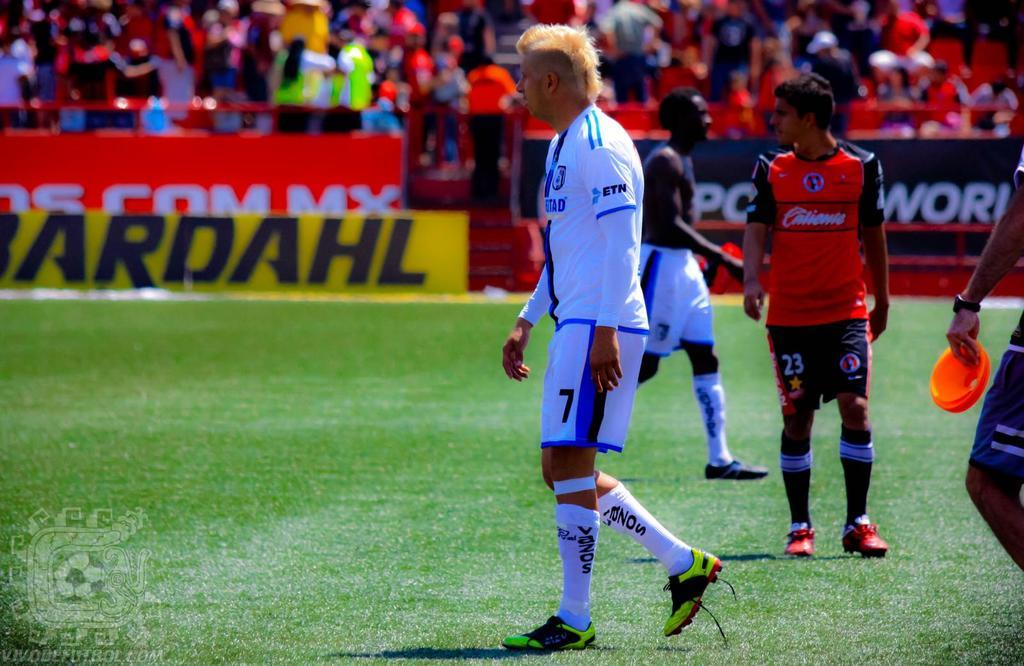Provide a one-sentence caption for the provided image. a group of players with Bardahl on a banner on the sidelines. 